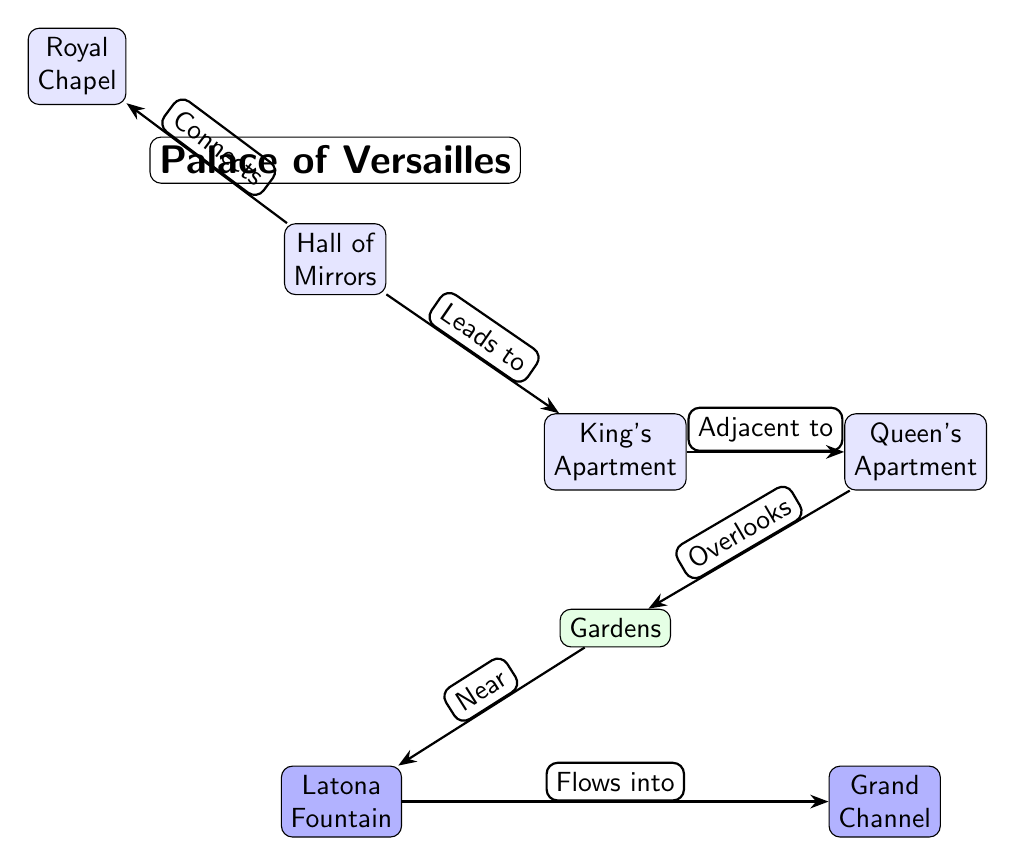What are the two main apartments in the Palace of Versailles? The diagram labels the two main apartments as the King's Apartment and the Queen's Apartment. These are positioned directly adjacent to each other on the right side of the Hall of Mirrors.
Answer: King's Apartment, Queen's Apartment Which area overlooks the gardens? According to the diagram, the Queen's Apartment is designated as overlooking the gardens, as indicated by the edge labeled "Overlooks" from the Queen's Apartment to the Gardens.
Answer: Queen's Apartment How many key areas are labeled in the diagram? The diagram includes a total of six key areas: Hall of Mirrors, King's Apartment, Queen's Apartment, Royal Chapel, Gardens, and Latona Fountain. Therefore, by counting all labeled nodes, we can find there are six.
Answer: 6 What connects the Hall of Mirrors and the Royal Chapel? The edge labeled "Connects" between the Hall of Mirrors and the Royal Chapel indicates that these two areas are connected. It shows a direct relationship between them as depicted in the diagram.
Answer: Royal Chapel What flows into the Grand Channel? The diagram specifies that the Latona Fountain, which is located near the Gardens, flows into the Grand Channel, as illustrated by the labeled edge "Flows into."
Answer: Grand Channel What is adjacent to the King's Apartment? The diagram indicates that the Queen's Apartment is directly adjacent to the King's Apartment, as shown by the edge labeled "Adjacent to."
Answer: Queen's Apartment In which direction are the Gardens located concerning the King's Apartment? From the diagram, the Gardens are located directly below the King's Apartment. This is indicated by the placement of the Gardens node in relation to the King's Apartment node.
Answer: Below What connects the Gardens to the Latona Fountain? The edge labeled "Near" identifies that the Gardens are in proximity to the Latona Fountain, establishing their relationship in the diagram.
Answer: Latona Fountain How is the Royal Chapel positioned relative to the Hall of Mirrors? The diagram shows the Royal Chapel positioned above and to the left of the Hall of Mirrors, as indicated by their respective nodes and the edge that connects them.
Answer: Above left 